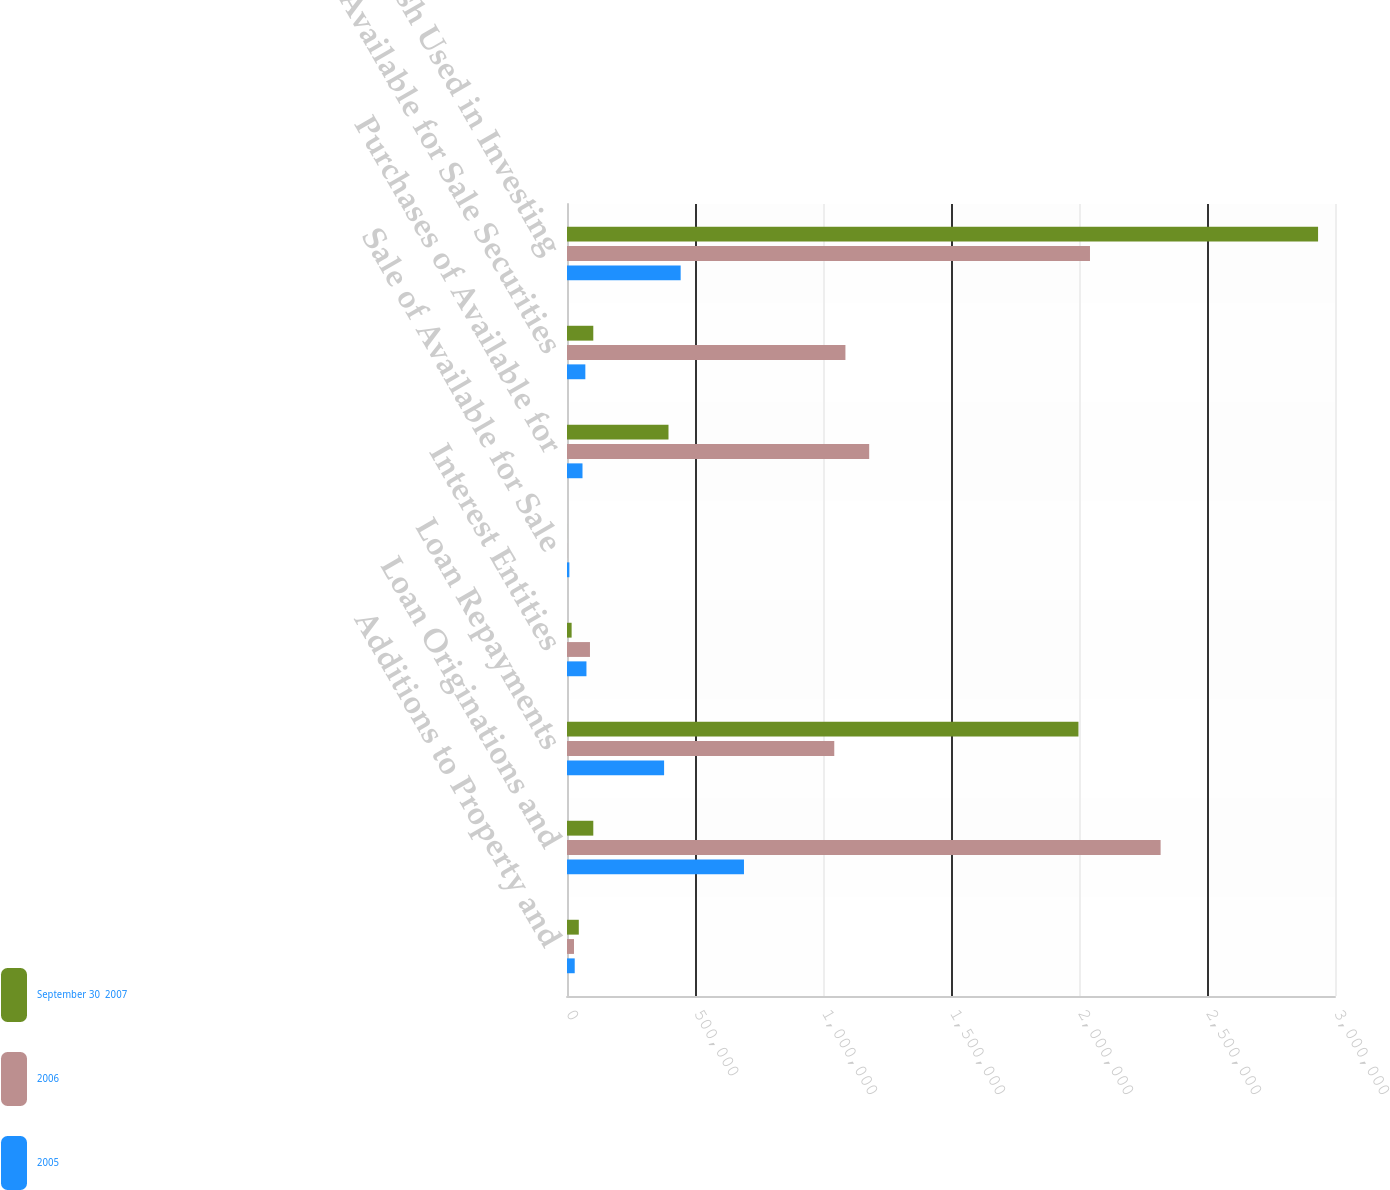<chart> <loc_0><loc_0><loc_500><loc_500><stacked_bar_chart><ecel><fcel>Additions to Property and<fcel>Loan Originations and<fcel>Loan Repayments<fcel>Interest Entities<fcel>Sale of Available for Sale<fcel>Purchases of Available for<fcel>Available for Sale Securities<fcel>Net Cash Used in Investing<nl><fcel>September 30  2007<fcel>46081<fcel>102700<fcel>1.99782e+06<fcel>18078<fcel>81<fcel>396450<fcel>102700<fcel>2.93386e+06<nl><fcel>2006<fcel>27280<fcel>2.31883e+06<fcel>1.04402e+06<fcel>89735<fcel>252<fcel>1.18041e+06<fcel>1.08762e+06<fcel>2.04291e+06<nl><fcel>2005<fcel>30154<fcel>691302<fcel>379298<fcel>75967<fcel>9250<fcel>60536<fcel>71671<fcel>444026<nl></chart> 